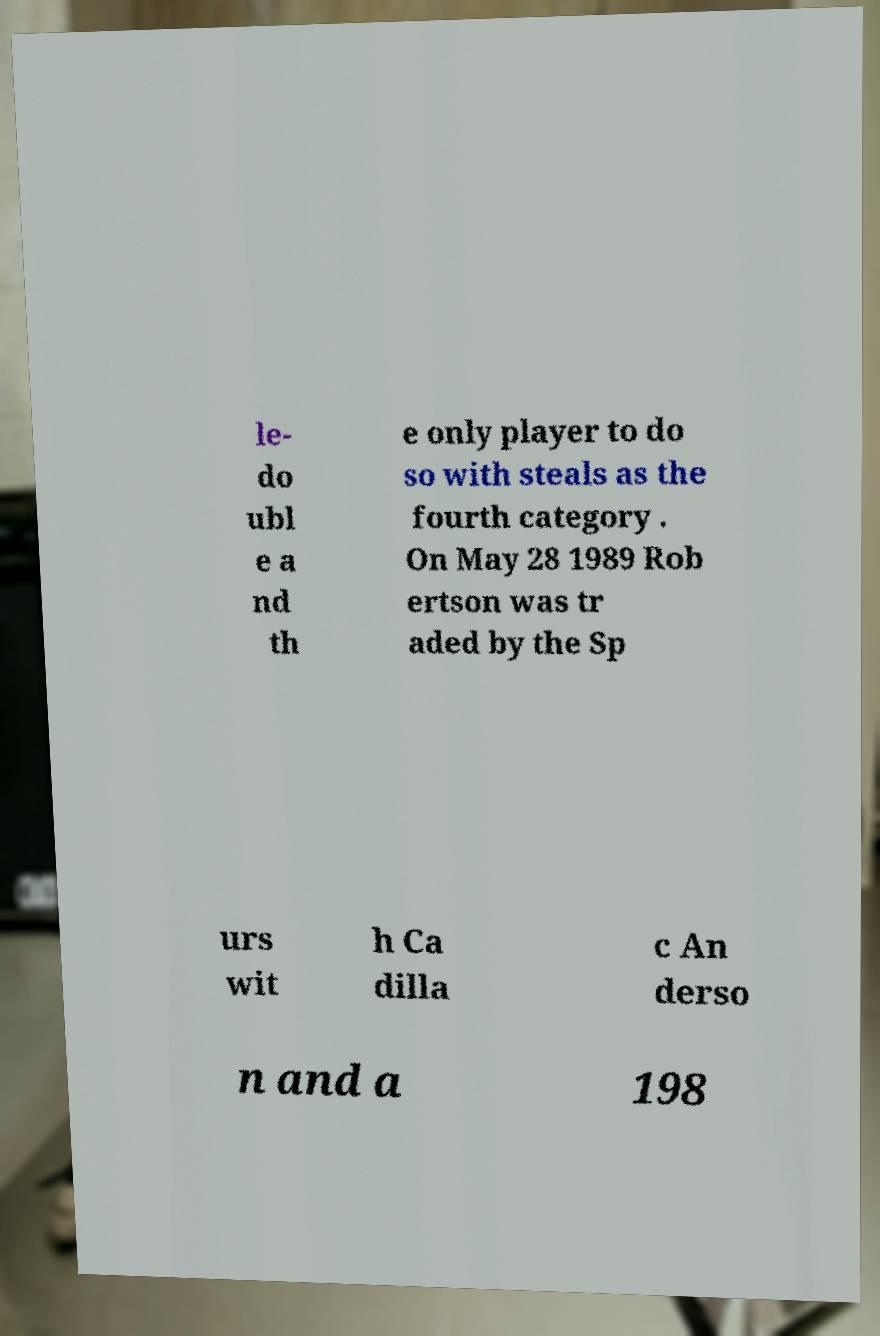Please read and relay the text visible in this image. What does it say? le- do ubl e a nd th e only player to do so with steals as the fourth category . On May 28 1989 Rob ertson was tr aded by the Sp urs wit h Ca dilla c An derso n and a 198 